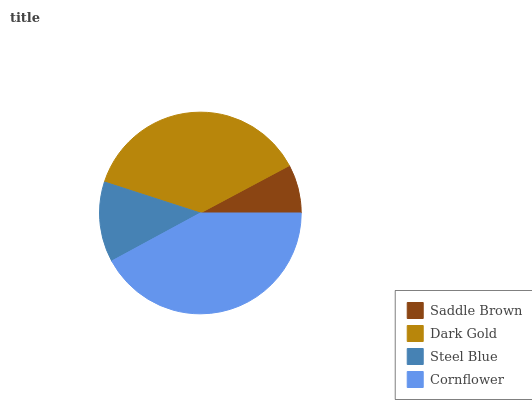Is Saddle Brown the minimum?
Answer yes or no. Yes. Is Cornflower the maximum?
Answer yes or no. Yes. Is Dark Gold the minimum?
Answer yes or no. No. Is Dark Gold the maximum?
Answer yes or no. No. Is Dark Gold greater than Saddle Brown?
Answer yes or no. Yes. Is Saddle Brown less than Dark Gold?
Answer yes or no. Yes. Is Saddle Brown greater than Dark Gold?
Answer yes or no. No. Is Dark Gold less than Saddle Brown?
Answer yes or no. No. Is Dark Gold the high median?
Answer yes or no. Yes. Is Steel Blue the low median?
Answer yes or no. Yes. Is Saddle Brown the high median?
Answer yes or no. No. Is Cornflower the low median?
Answer yes or no. No. 